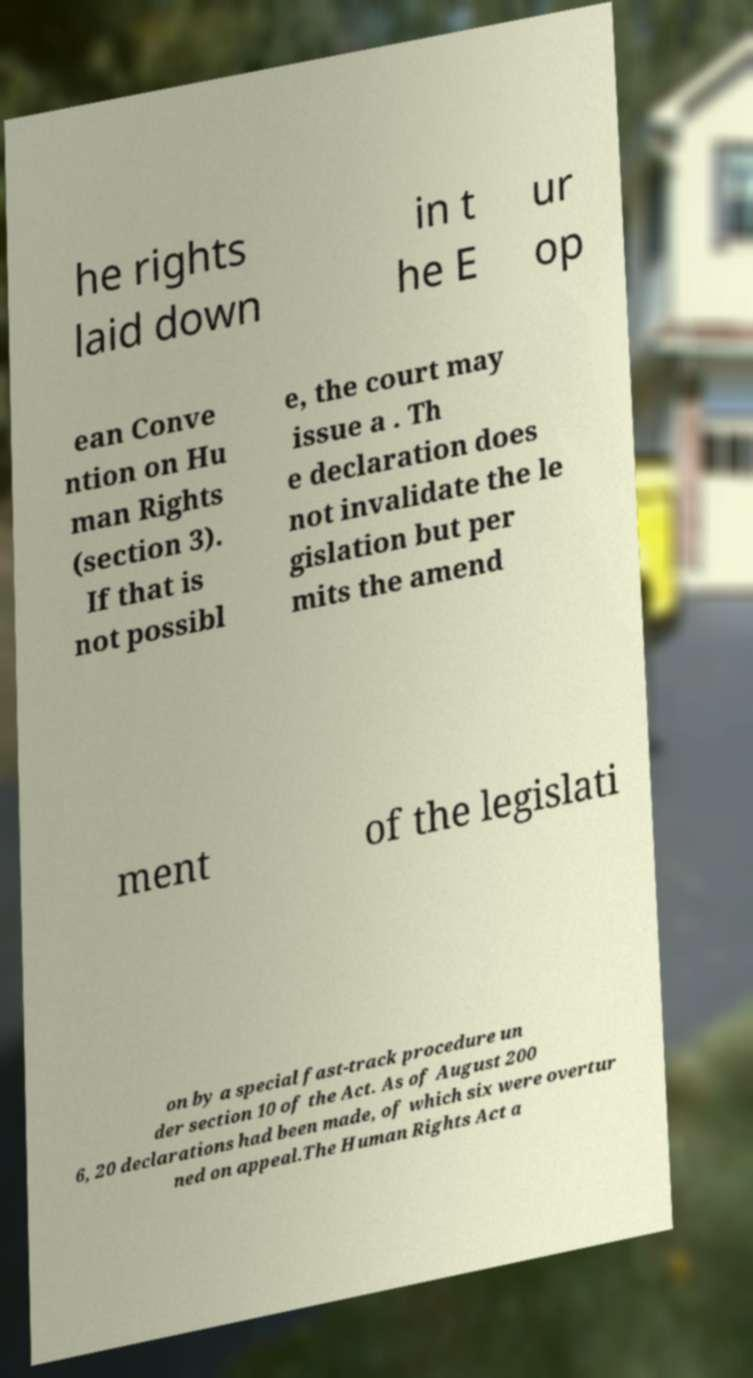Can you accurately transcribe the text from the provided image for me? he rights laid down in t he E ur op ean Conve ntion on Hu man Rights (section 3). If that is not possibl e, the court may issue a . Th e declaration does not invalidate the le gislation but per mits the amend ment of the legislati on by a special fast-track procedure un der section 10 of the Act. As of August 200 6, 20 declarations had been made, of which six were overtur ned on appeal.The Human Rights Act a 